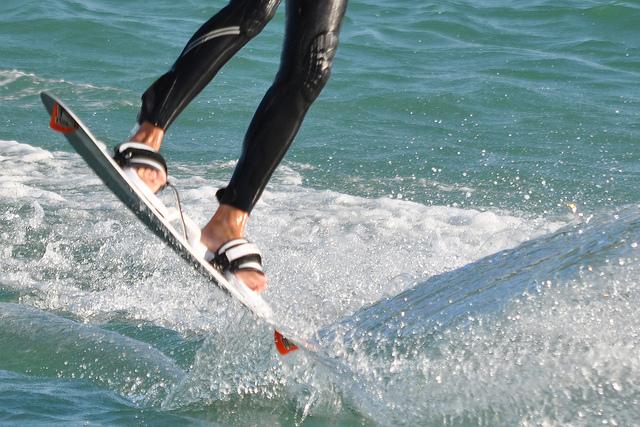What color is the water?
Give a very brief answer. Blue. Is it summer?
Quick response, please. Yes. Is the person in the photo wearing tennis shoes?
Write a very short answer. No. 